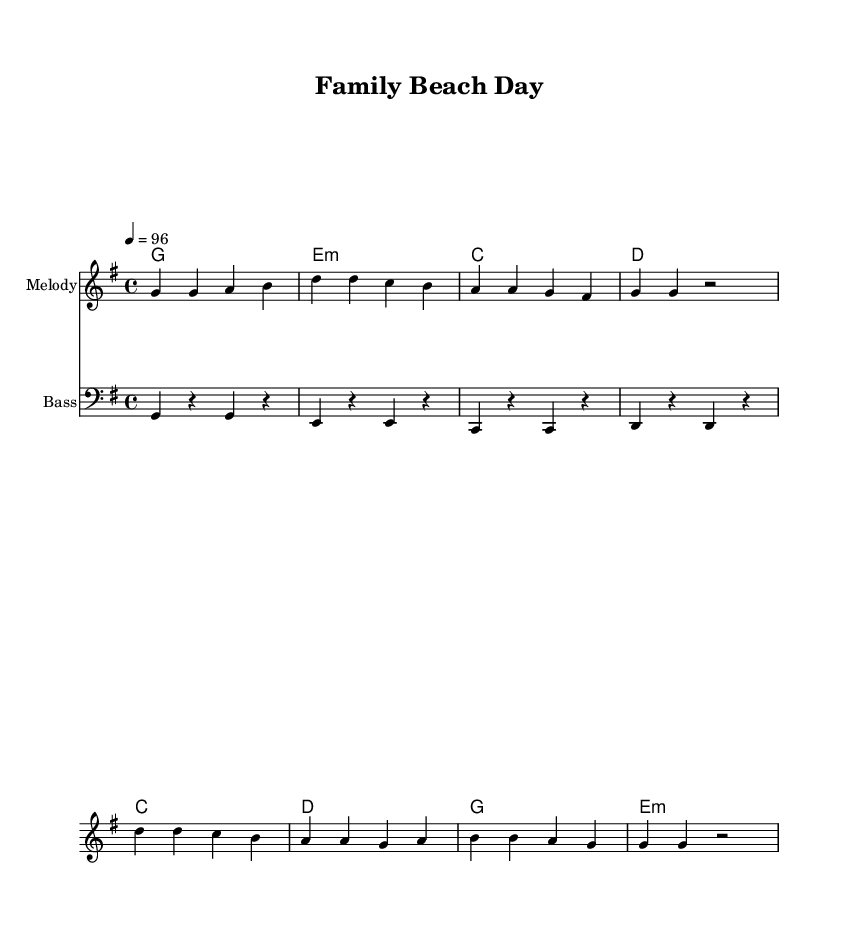What is the key signature of this music? The key signature is G major, which has one sharp (F#). This can be identified by looking at the initial part of the sheet music where the key signature is indicated.
Answer: G major What is the time signature of this music? The time signature is 4/4, which means there are four beats in a measure and the quarter note gets one beat. This is shown at the beginning of the music, right after the key signature.
Answer: 4/4 What tempo marking is indicated in the score? The tempo marking is quarter note equals 96. This is indicated in the tempo section of the music above the staff. It tells how fast the music should be played.
Answer: 96 What is the first note of the melody? The first note of the melody is G. This can be found by looking at the beginning of the melody staff where the notes are written.
Answer: G How many measures are there in the verse? There are four measures in the verse. This is determined by counting each measure indicated by the vertical lines in the sheet music within the verse section.
Answer: 4 What type of chord is played during the first measure of the verse? The first chord in the verse is G major. This can be identified by looking at the chord names placed above the melody staff at the beginning of the verse.
Answer: G major What positive message is conveyed in the chorus lyrics? The chorus conveys the message of family togetherness and love growing. This is reflected in the lyrics that emphasize creating memories and holding on to love, which supports family bonding themes.
Answer: Family love continues to grow 